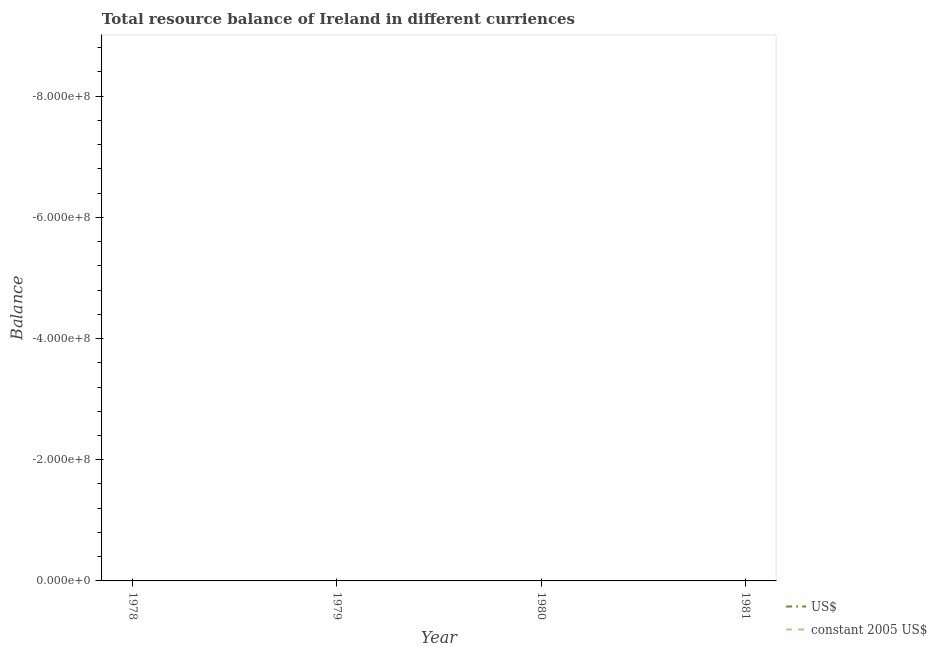How many different coloured lines are there?
Your answer should be compact. 0. Does the line corresponding to resource balance in us$ intersect with the line corresponding to resource balance in constant us$?
Offer a very short reply. No. Is the number of lines equal to the number of legend labels?
Give a very brief answer. No. Across all years, what is the minimum resource balance in us$?
Your response must be concise. 0. What is the total resource balance in us$ in the graph?
Your answer should be very brief. 0. What is the difference between the resource balance in constant us$ in 1979 and the resource balance in us$ in 1980?
Offer a very short reply. 0. What is the average resource balance in us$ per year?
Your response must be concise. 0. In how many years, is the resource balance in constant us$ greater than the average resource balance in constant us$ taken over all years?
Make the answer very short. 0. Does the resource balance in constant us$ monotonically increase over the years?
Your answer should be compact. No. Is the resource balance in us$ strictly greater than the resource balance in constant us$ over the years?
Your answer should be compact. No. How many years are there in the graph?
Your response must be concise. 4. Are the values on the major ticks of Y-axis written in scientific E-notation?
Offer a very short reply. Yes. What is the title of the graph?
Make the answer very short. Total resource balance of Ireland in different curriences. What is the label or title of the Y-axis?
Your response must be concise. Balance. What is the Balance in constant 2005 US$ in 1978?
Keep it short and to the point. 0. What is the Balance in constant 2005 US$ in 1979?
Provide a short and direct response. 0. What is the total Balance in US$ in the graph?
Make the answer very short. 0. What is the total Balance of constant 2005 US$ in the graph?
Ensure brevity in your answer.  0. 